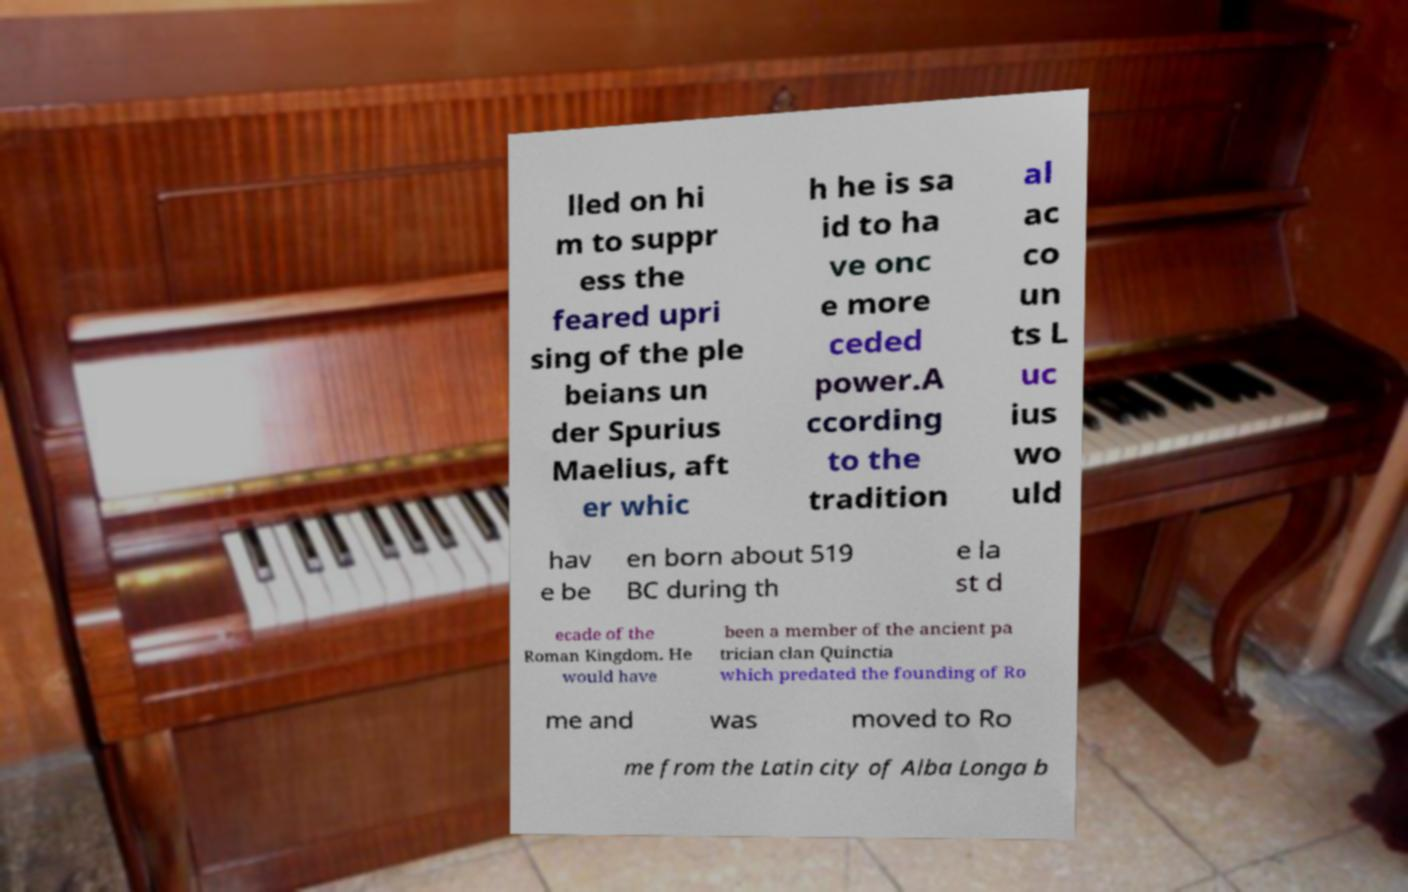For documentation purposes, I need the text within this image transcribed. Could you provide that? lled on hi m to suppr ess the feared upri sing of the ple beians un der Spurius Maelius, aft er whic h he is sa id to ha ve onc e more ceded power.A ccording to the tradition al ac co un ts L uc ius wo uld hav e be en born about 519 BC during th e la st d ecade of the Roman Kingdom. He would have been a member of the ancient pa trician clan Quinctia which predated the founding of Ro me and was moved to Ro me from the Latin city of Alba Longa b 